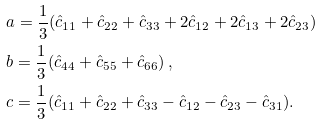Convert formula to latex. <formula><loc_0><loc_0><loc_500><loc_500>& a = \frac { 1 } { 3 } ( \hat { c } _ { 1 1 } + \hat { c } _ { 2 2 } + \hat { c } _ { 3 3 } + 2 \hat { c } _ { 1 2 } + 2 \hat { c } _ { 1 3 } + 2 \hat { c } _ { 2 3 } ) \\ & b = \frac { 1 } { 3 } ( \hat { c } _ { 4 4 } + \hat { c } _ { 5 5 } + \hat { c } _ { 6 6 } ) \, , \\ & c = \frac { 1 } { 3 } ( \hat { c } _ { 1 1 } + \hat { c } _ { 2 2 } + \hat { c } _ { 3 3 } - \hat { c } _ { 1 2 } - \hat { c } _ { 2 3 } - \hat { c } _ { 3 1 } ) .</formula> 